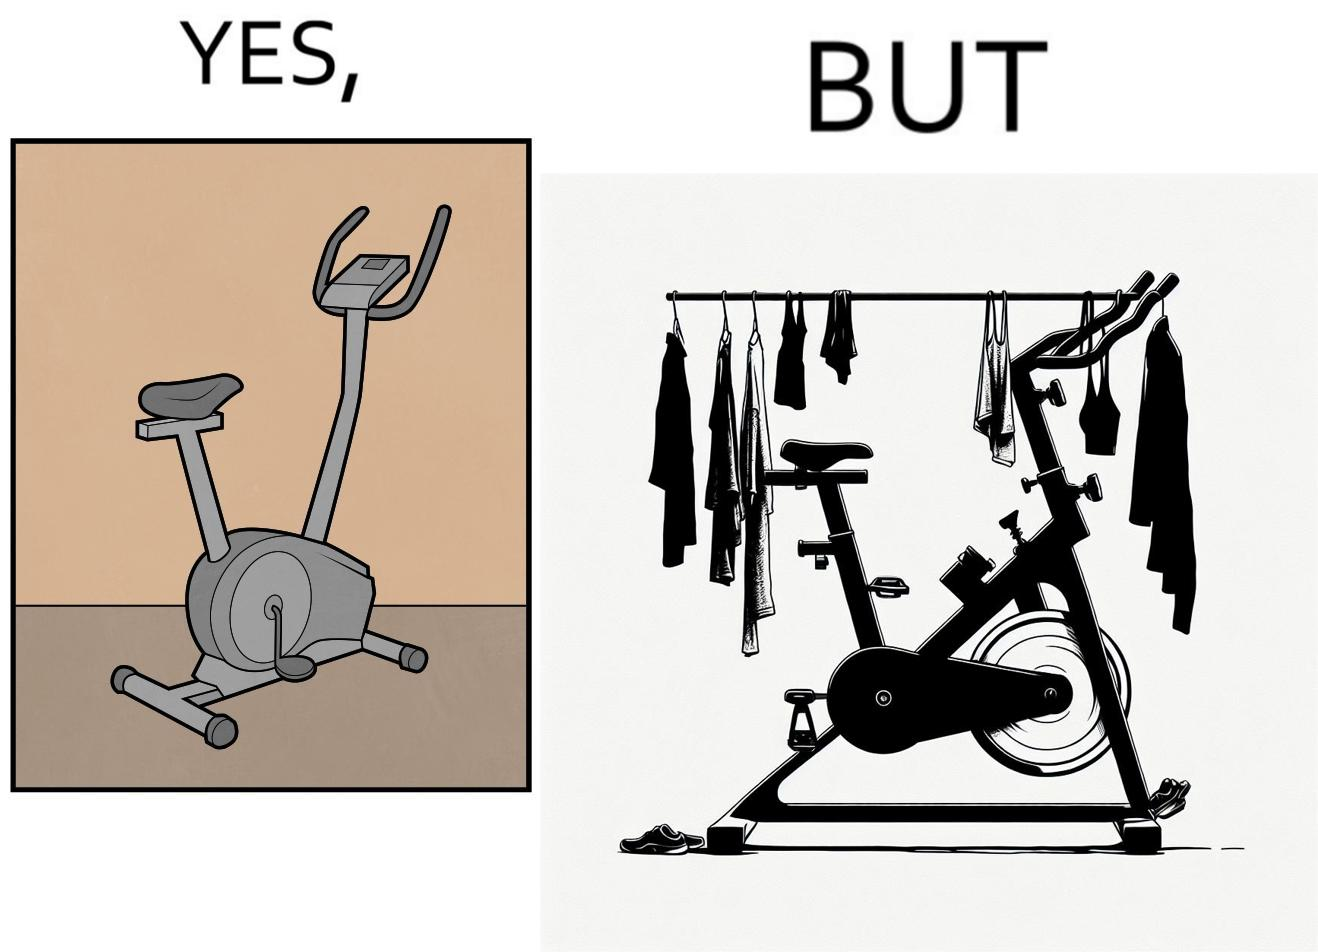Describe the satirical element in this image. The images are funny since they show an exercise bike has been bought but is not being used for its purpose, that is, exercising. It is rather being used to hang clothes, bags and other items 